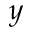Convert formula to latex. <formula><loc_0><loc_0><loc_500><loc_500>y</formula> 